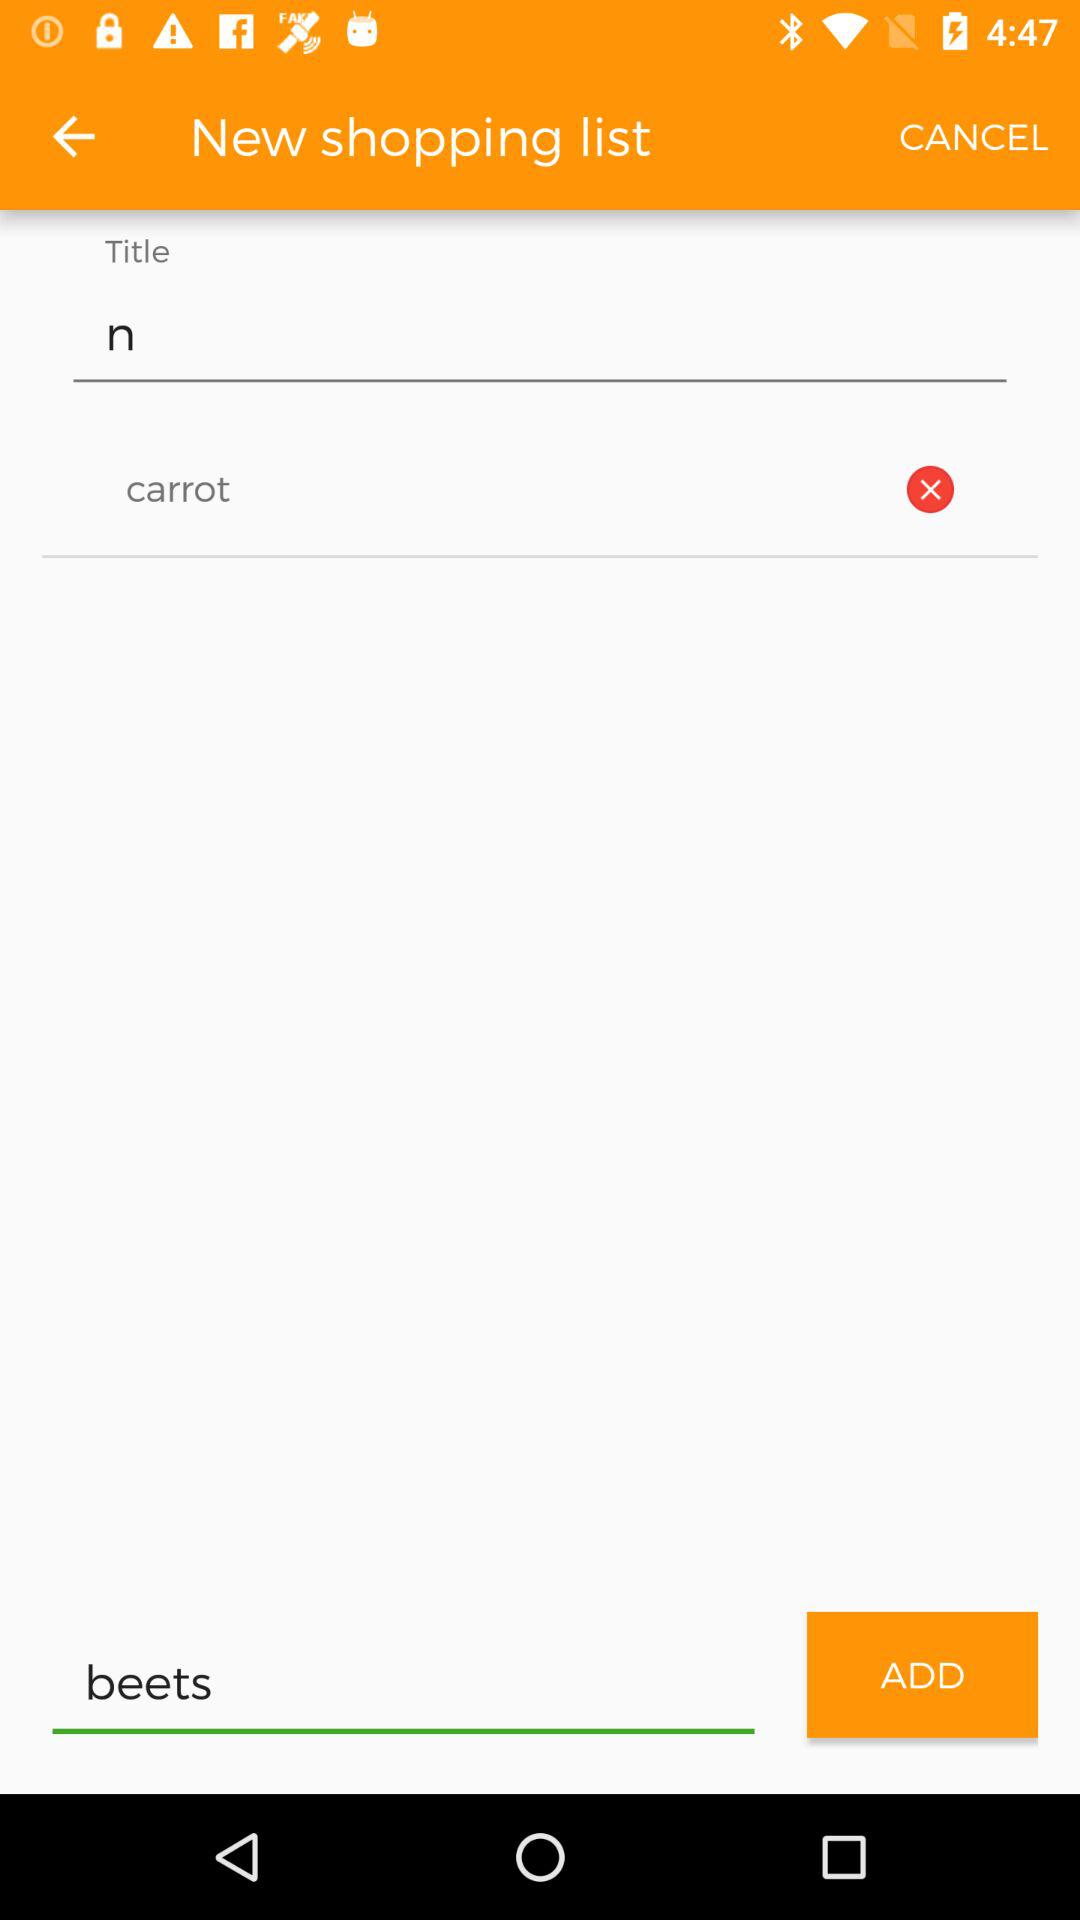What item is entered to add? The entered item is "beets". 